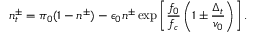Convert formula to latex. <formula><loc_0><loc_0><loc_500><loc_500>n _ { t } ^ { \pm } = \pi _ { 0 } ( 1 - n ^ { \pm } ) - \epsilon _ { 0 } n ^ { \pm } \exp \left [ \frac { f _ { 0 } } { f _ { c } } \left ( 1 \pm \frac { \Delta _ { t } } { v _ { 0 } } \right ) \right ] .</formula> 